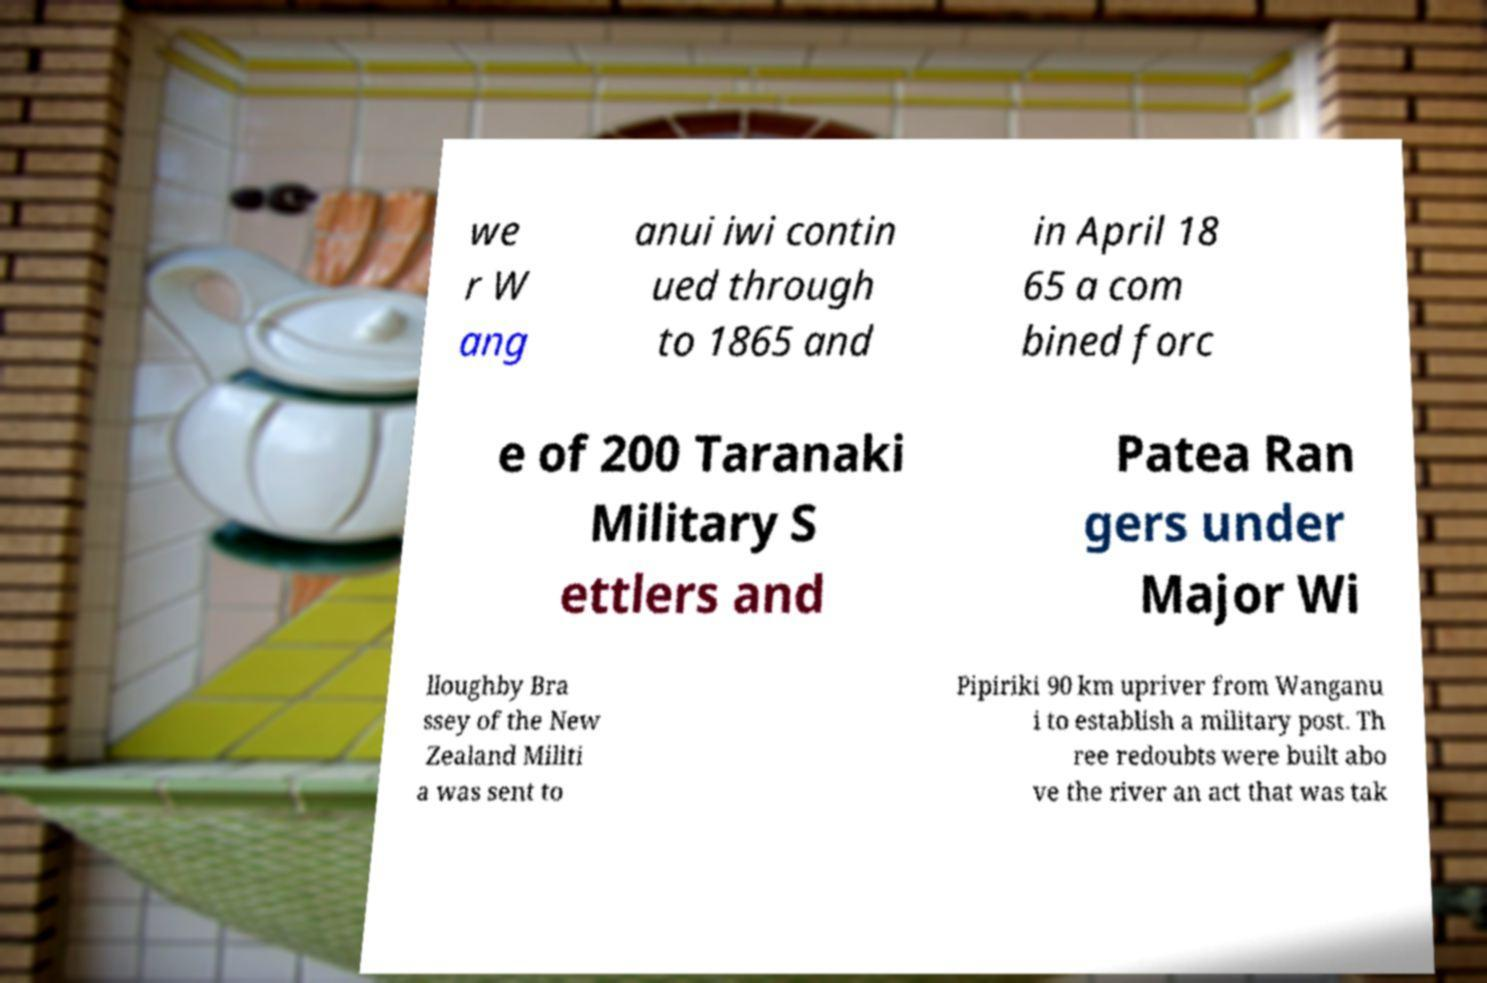Can you accurately transcribe the text from the provided image for me? we r W ang anui iwi contin ued through to 1865 and in April 18 65 a com bined forc e of 200 Taranaki Military S ettlers and Patea Ran gers under Major Wi lloughby Bra ssey of the New Zealand Militi a was sent to Pipiriki 90 km upriver from Wanganu i to establish a military post. Th ree redoubts were built abo ve the river an act that was tak 